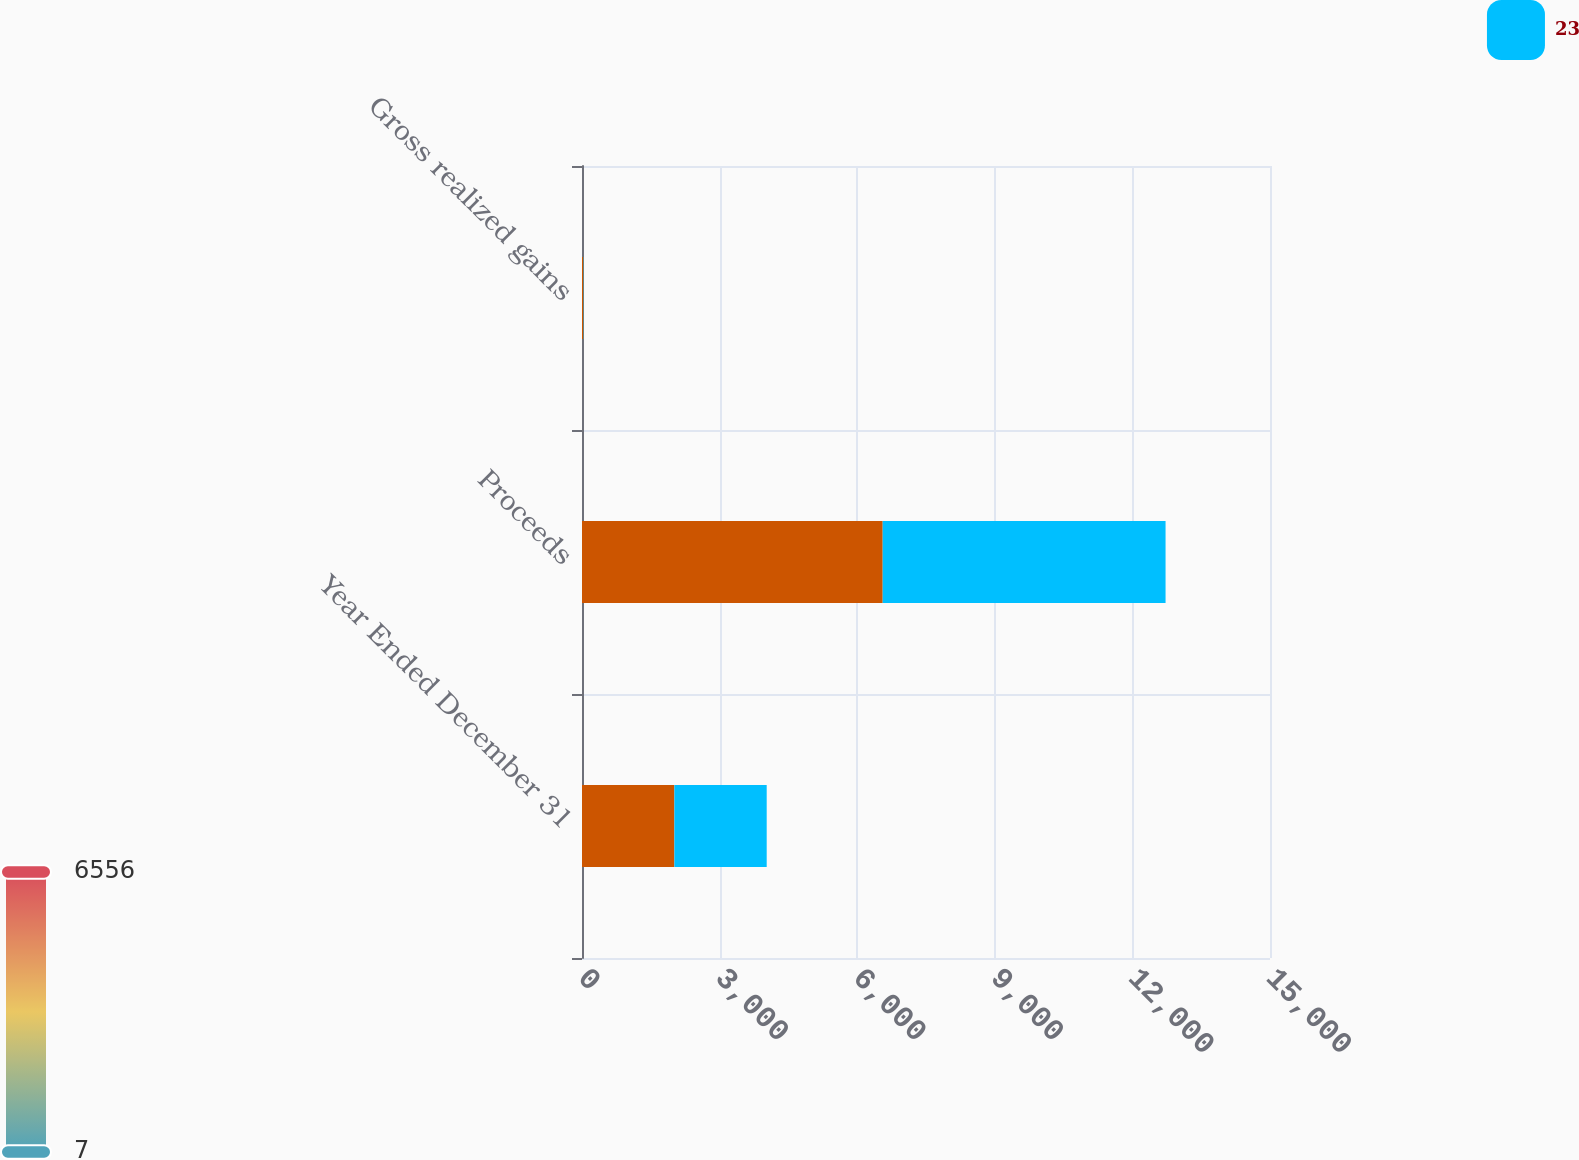Convert chart. <chart><loc_0><loc_0><loc_500><loc_500><stacked_bar_chart><ecel><fcel>Year Ended December 31<fcel>Proceeds<fcel>Gross realized gains<nl><fcel>nan<fcel>2014<fcel>6556<fcel>30<nl><fcel>23<fcel>2013<fcel>6167<fcel>7<nl></chart> 